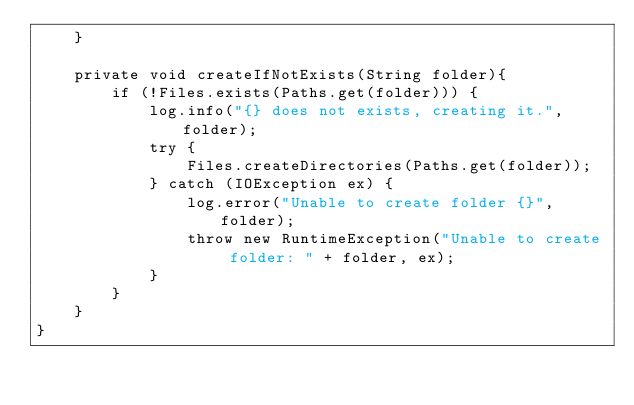Convert code to text. <code><loc_0><loc_0><loc_500><loc_500><_Java_>    }

    private void createIfNotExists(String folder){
        if (!Files.exists(Paths.get(folder))) {
            log.info("{} does not exists, creating it.", folder);
            try {
                Files.createDirectories(Paths.get(folder));
            } catch (IOException ex) {
                log.error("Unable to create folder {}", folder);
                throw new RuntimeException("Unable to create folder: " + folder, ex);
            }
        }
    }
}
</code> 